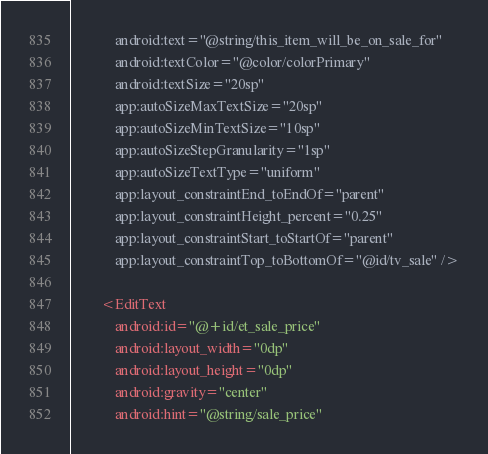Convert code to text. <code><loc_0><loc_0><loc_500><loc_500><_XML_>            android:text="@string/this_item_will_be_on_sale_for"
            android:textColor="@color/colorPrimary"
            android:textSize="20sp"
            app:autoSizeMaxTextSize="20sp"
            app:autoSizeMinTextSize="10sp"
            app:autoSizeStepGranularity="1sp"
            app:autoSizeTextType="uniform"
            app:layout_constraintEnd_toEndOf="parent"
            app:layout_constraintHeight_percent="0.25"
            app:layout_constraintStart_toStartOf="parent"
            app:layout_constraintTop_toBottomOf="@id/tv_sale" />

        <EditText
            android:id="@+id/et_sale_price"
            android:layout_width="0dp"
            android:layout_height="0dp"
            android:gravity="center"
            android:hint="@string/sale_price"</code> 